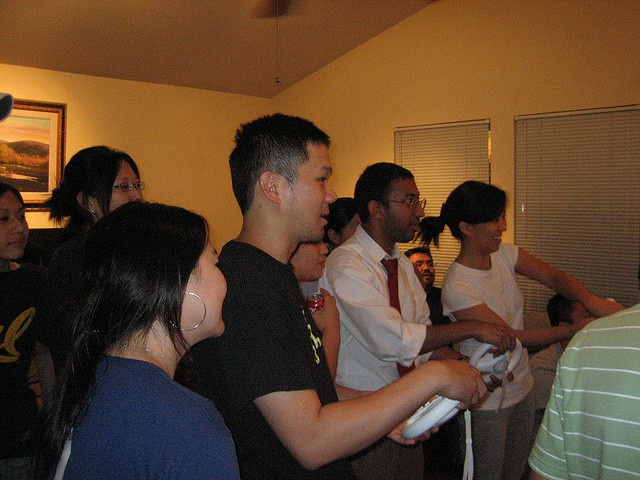Describe the objects in this image and their specific colors. I can see people in maroon, black, and brown tones, people in maroon, black, navy, and gray tones, people in maroon, black, and gray tones, people in maroon, black, and gray tones, and people in maroon, gray, and darkgray tones in this image. 